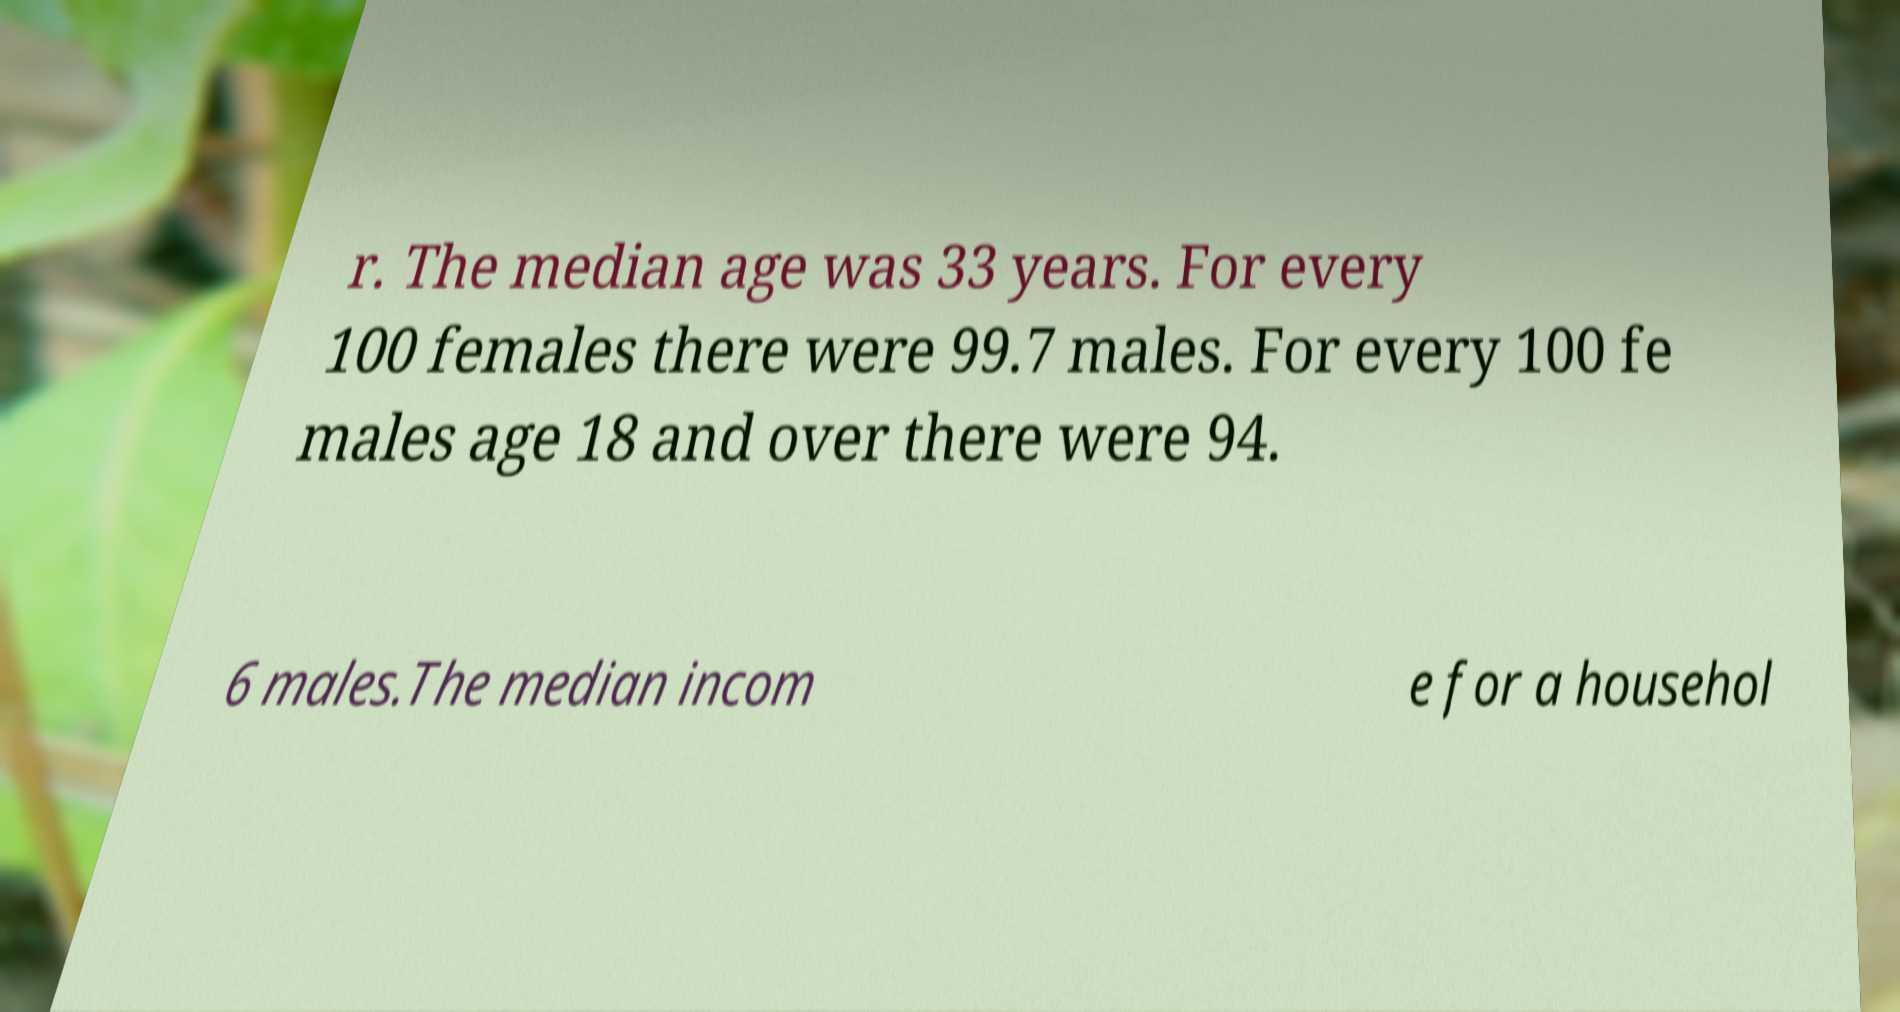Can you accurately transcribe the text from the provided image for me? r. The median age was 33 years. For every 100 females there were 99.7 males. For every 100 fe males age 18 and over there were 94. 6 males.The median incom e for a househol 